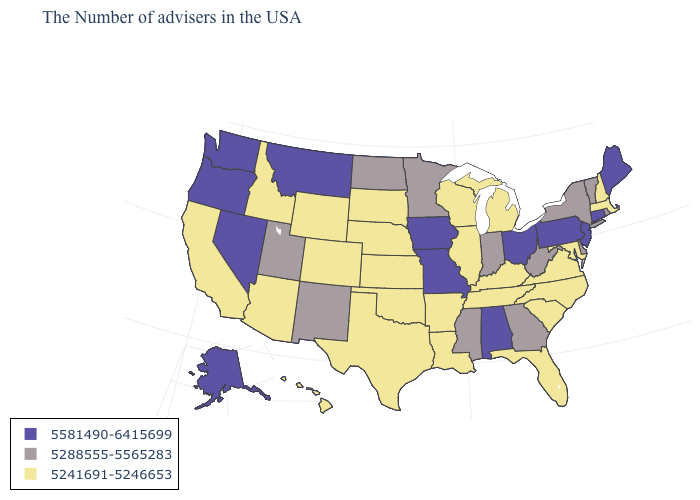Name the states that have a value in the range 5241691-5246653?
Quick response, please. Massachusetts, New Hampshire, Maryland, Virginia, North Carolina, South Carolina, Florida, Michigan, Kentucky, Tennessee, Wisconsin, Illinois, Louisiana, Arkansas, Kansas, Nebraska, Oklahoma, Texas, South Dakota, Wyoming, Colorado, Arizona, Idaho, California, Hawaii. What is the value of Arizona?
Be succinct. 5241691-5246653. Name the states that have a value in the range 5241691-5246653?
Write a very short answer. Massachusetts, New Hampshire, Maryland, Virginia, North Carolina, South Carolina, Florida, Michigan, Kentucky, Tennessee, Wisconsin, Illinois, Louisiana, Arkansas, Kansas, Nebraska, Oklahoma, Texas, South Dakota, Wyoming, Colorado, Arizona, Idaho, California, Hawaii. Which states have the lowest value in the Northeast?
Be succinct. Massachusetts, New Hampshire. What is the lowest value in the USA?
Give a very brief answer. 5241691-5246653. Name the states that have a value in the range 5241691-5246653?
Be succinct. Massachusetts, New Hampshire, Maryland, Virginia, North Carolina, South Carolina, Florida, Michigan, Kentucky, Tennessee, Wisconsin, Illinois, Louisiana, Arkansas, Kansas, Nebraska, Oklahoma, Texas, South Dakota, Wyoming, Colorado, Arizona, Idaho, California, Hawaii. Among the states that border Montana , which have the lowest value?
Short answer required. South Dakota, Wyoming, Idaho. Name the states that have a value in the range 5241691-5246653?
Concise answer only. Massachusetts, New Hampshire, Maryland, Virginia, North Carolina, South Carolina, Florida, Michigan, Kentucky, Tennessee, Wisconsin, Illinois, Louisiana, Arkansas, Kansas, Nebraska, Oklahoma, Texas, South Dakota, Wyoming, Colorado, Arizona, Idaho, California, Hawaii. What is the value of New York?
Concise answer only. 5288555-5565283. Does the map have missing data?
Write a very short answer. No. Name the states that have a value in the range 5241691-5246653?
Keep it brief. Massachusetts, New Hampshire, Maryland, Virginia, North Carolina, South Carolina, Florida, Michigan, Kentucky, Tennessee, Wisconsin, Illinois, Louisiana, Arkansas, Kansas, Nebraska, Oklahoma, Texas, South Dakota, Wyoming, Colorado, Arizona, Idaho, California, Hawaii. What is the highest value in the USA?
Quick response, please. 5581490-6415699. What is the value of Wisconsin?
Give a very brief answer. 5241691-5246653. What is the highest value in the West ?
Short answer required. 5581490-6415699. What is the value of Rhode Island?
Quick response, please. 5288555-5565283. 